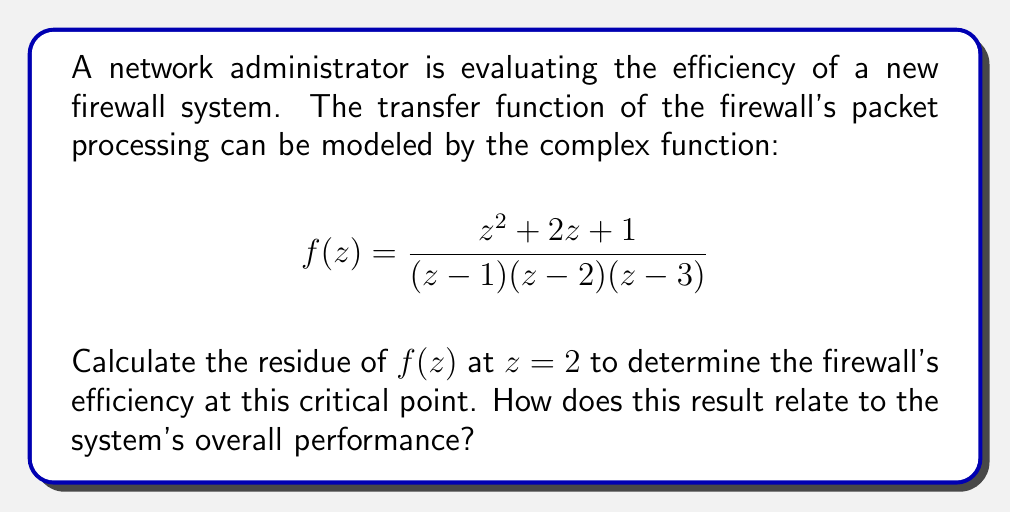Show me your answer to this math problem. To evaluate the residue of $f(z)$ at $z=2$, we'll use the residue theorem from complex analysis. The residue at a simple pole can be calculated using the formula:

$$\text{Res}(f,a) = \lim_{z \to a} (z-a)f(z)$$

Where $a$ is the pole (in this case, $a=2$).

Step 1: Rewrite the function to isolate the factor $(z-2)$:
$$f(z) = \frac{z^2 + 2z + 1}{(z-1)(z-2)(z-3)} = \frac{z^2 + 2z + 1}{(z-1)(z-3)} \cdot \frac{1}{z-2}$$

Step 2: Apply the residue formula:
$$\text{Res}(f,2) = \lim_{z \to 2} (z-2)f(z) = \lim_{z \to 2} \frac{z^2 + 2z + 1}{(z-1)(z-3)}$$

Step 3: Evaluate the limit:
$$\text{Res}(f,2) = \frac{2^2 + 2(2) + 1}{(2-1)(2-3)} = \frac{8 + 4 + 1}{(1)(-1)} = -13$$

The residue at $z=2$ is -13. In the context of firewall efficiency, this value represents the system's response at a critical processing point. A larger absolute value of the residue indicates a stronger response or higher sensitivity at this point.

For overall system performance, we would need to consider:
1. Residues at other poles ($z=1$ and $z=3$)
2. The behavior of $f(z)$ as $z$ approaches infinity
3. Any zeros of the function

The negative sign of the residue suggests that the firewall might have an inverse or compensating effect at this critical point, potentially indicating a stability mechanism in the packet processing algorithm.
Answer: The residue of $f(z)$ at $z=2$ is $-13$. This indicates a significant and inverse response at this critical point in the firewall's packet processing function, which may contribute to the system's stability and overall efficiency. 